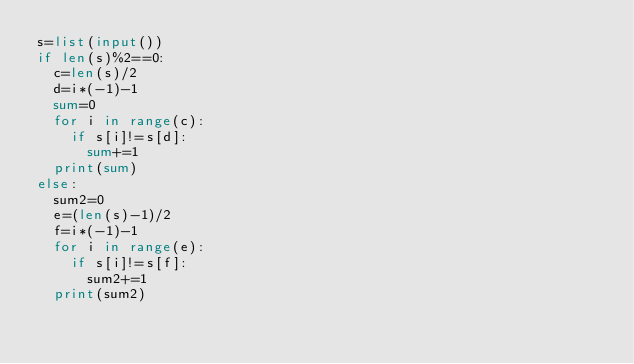Convert code to text. <code><loc_0><loc_0><loc_500><loc_500><_Python_>s=list(input())
if len(s)%2==0:
  c=len(s)/2
  d=i*(-1)-1
  sum=0
  for i in range(c):
    if s[i]!=s[d]:
      sum+=1
  print(sum)
else:
  sum2=0
  e=(len(s)-1)/2
  f=i*(-1)-1
  for i in range(e):
    if s[i]!=s[f]:
      sum2+=1
  print(sum2)</code> 